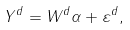Convert formula to latex. <formula><loc_0><loc_0><loc_500><loc_500>Y ^ { d } = W ^ { d } \alpha + \varepsilon ^ { d } ,</formula> 